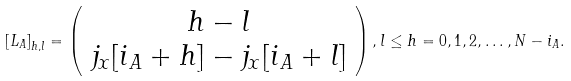Convert formula to latex. <formula><loc_0><loc_0><loc_500><loc_500>\left [ { L } _ { A } \right ] _ { h , l } = \left ( \begin{array} { c } h - l \\ j _ { x } [ i _ { A } + h ] - j _ { x } [ i _ { A } + l ] \end{array} \right ) , l \leq h = 0 , 1 , 2 , \dots , N - i _ { A } .</formula> 